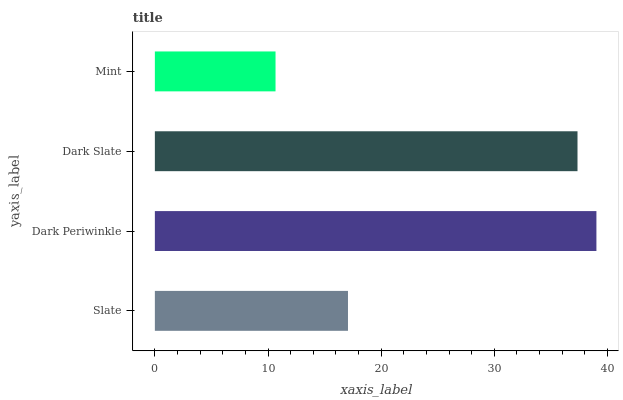Is Mint the minimum?
Answer yes or no. Yes. Is Dark Periwinkle the maximum?
Answer yes or no. Yes. Is Dark Slate the minimum?
Answer yes or no. No. Is Dark Slate the maximum?
Answer yes or no. No. Is Dark Periwinkle greater than Dark Slate?
Answer yes or no. Yes. Is Dark Slate less than Dark Periwinkle?
Answer yes or no. Yes. Is Dark Slate greater than Dark Periwinkle?
Answer yes or no. No. Is Dark Periwinkle less than Dark Slate?
Answer yes or no. No. Is Dark Slate the high median?
Answer yes or no. Yes. Is Slate the low median?
Answer yes or no. Yes. Is Slate the high median?
Answer yes or no. No. Is Dark Periwinkle the low median?
Answer yes or no. No. 